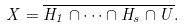<formula> <loc_0><loc_0><loc_500><loc_500>X = \overline { H _ { 1 } \cap \cdots \cap H _ { s } \cap U } .</formula> 